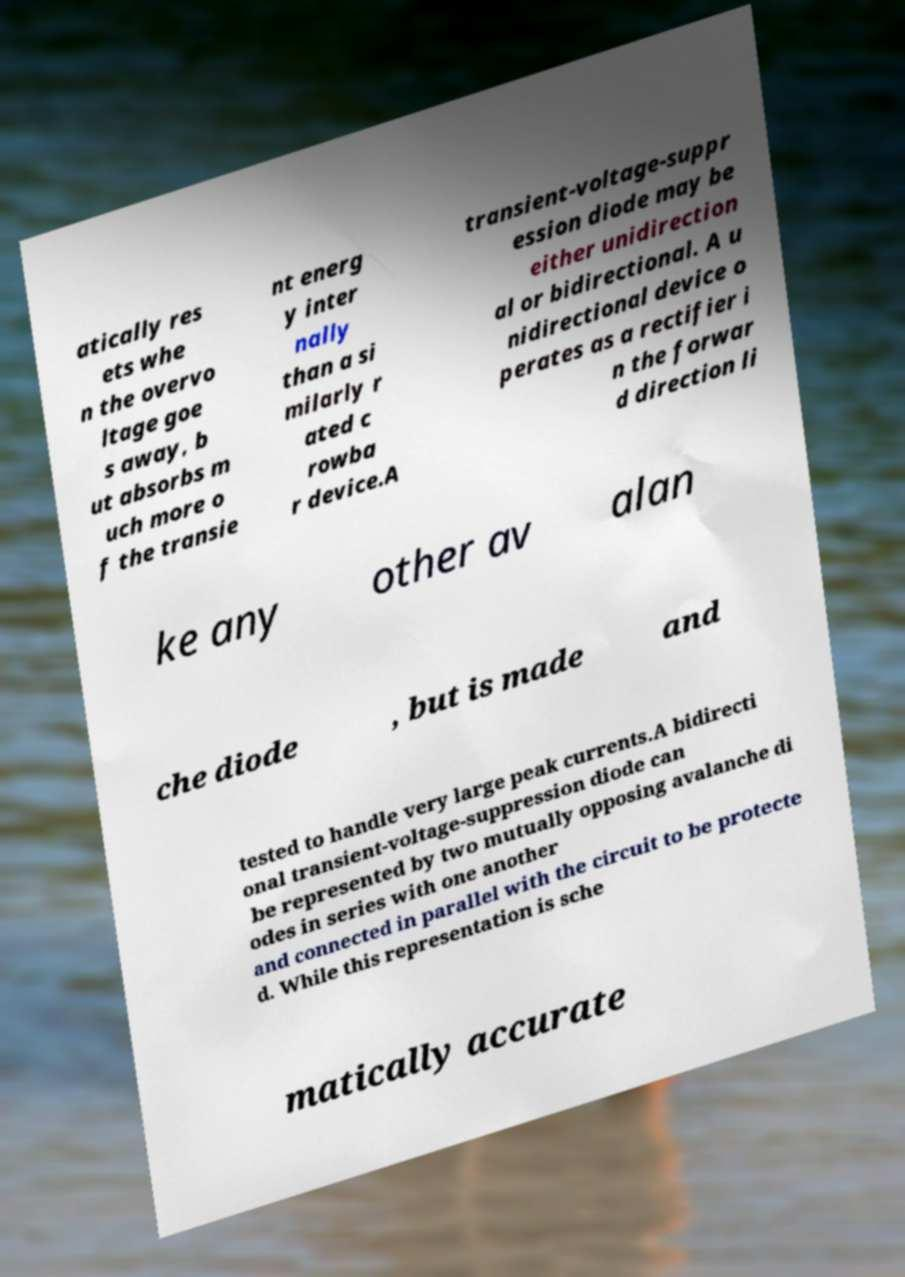There's text embedded in this image that I need extracted. Can you transcribe it verbatim? atically res ets whe n the overvo ltage goe s away, b ut absorbs m uch more o f the transie nt energ y inter nally than a si milarly r ated c rowba r device.A transient-voltage-suppr ession diode may be either unidirection al or bidirectional. A u nidirectional device o perates as a rectifier i n the forwar d direction li ke any other av alan che diode , but is made and tested to handle very large peak currents.A bidirecti onal transient-voltage-suppression diode can be represented by two mutually opposing avalanche di odes in series with one another and connected in parallel with the circuit to be protecte d. While this representation is sche matically accurate 